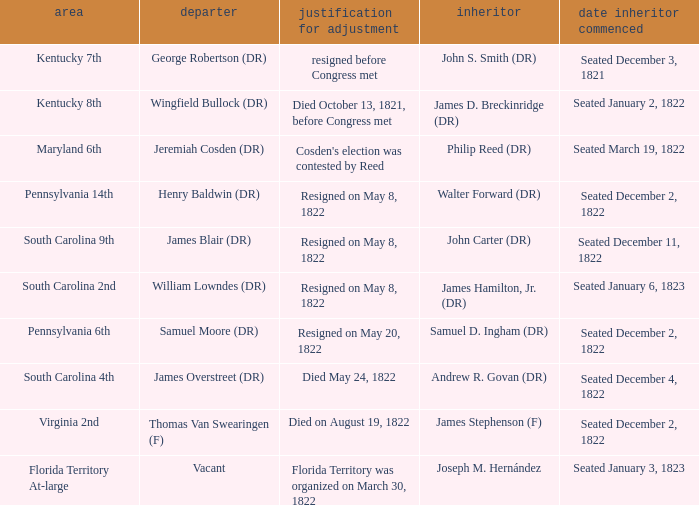Who is the successor when florida territory at-large is the district? Joseph M. Hernández. 